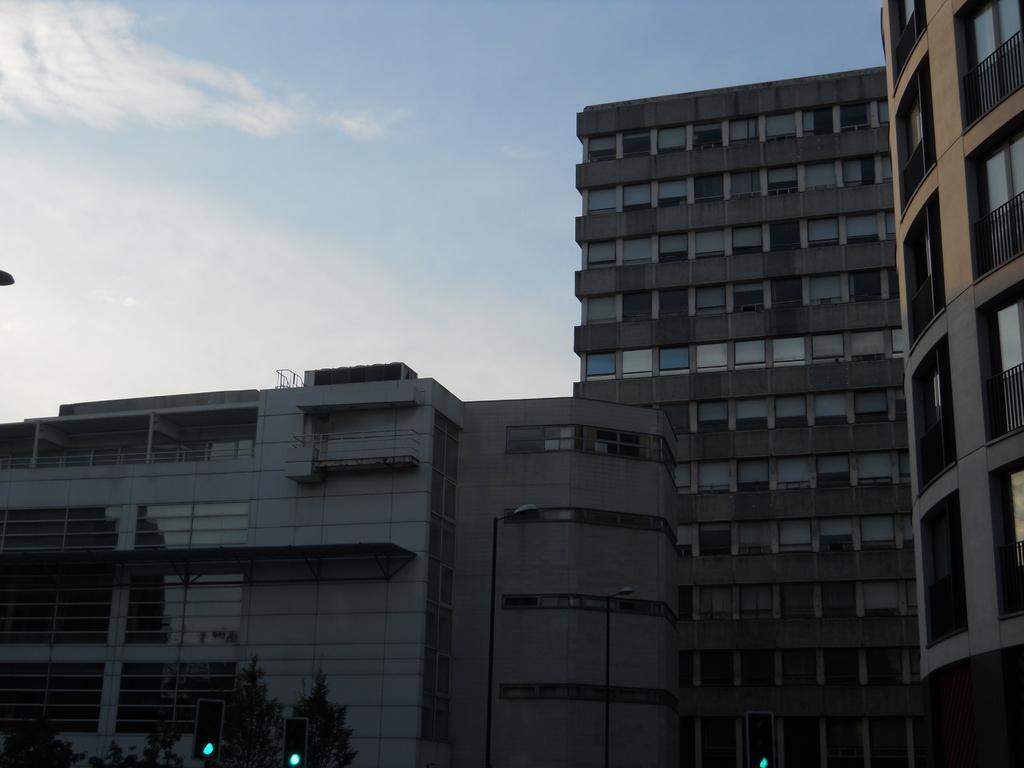Could you give a brief overview of what you see in this image? In this image we can see buildings, poles, lights, traffic signals, and branches. In the background there is sky with clouds. 